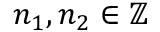Convert formula to latex. <formula><loc_0><loc_0><loc_500><loc_500>n _ { 1 } , n _ { 2 } \in \mathbb { Z }</formula> 